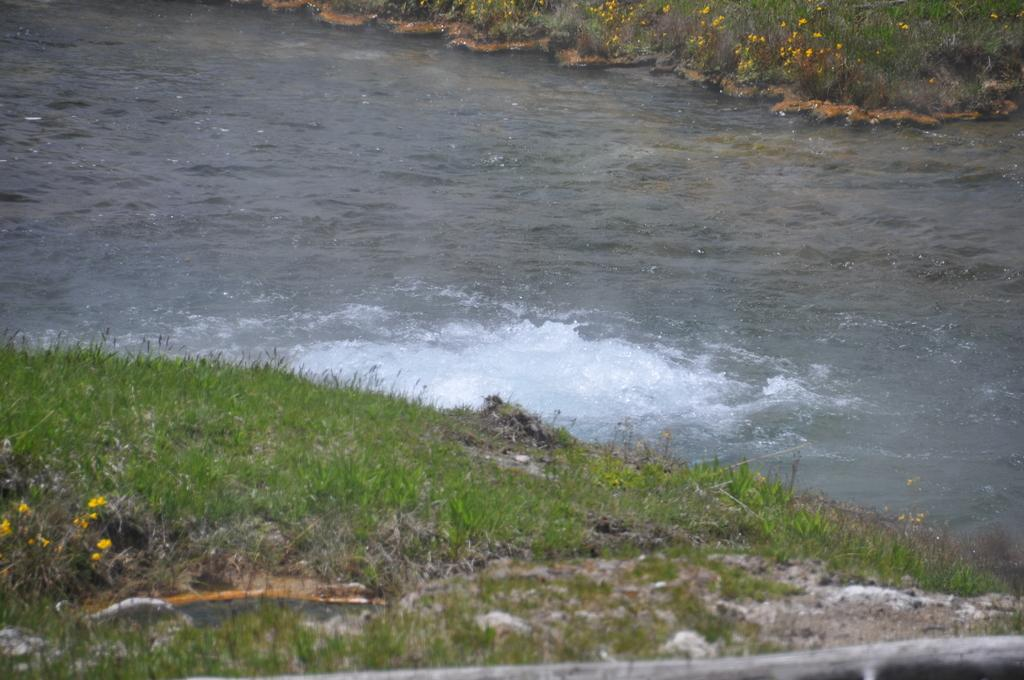What type of vegetation can be seen in the image? There is grass and plants with tiny yellow flowers in the image. What is the primary feature of the plants with tiny yellow flowers? The primary feature of the plants with tiny yellow flowers is their small, yellow flowers. Can you describe the movement of water in the image? Yes, there is water flowing in the image. What arithmetic problem is being solved by the hands in the image? There are no hands or arithmetic problems present in the image. What type of engine can be seen powering the water flow in the image? There is no engine present in the image; the water flow is a natural occurrence. 